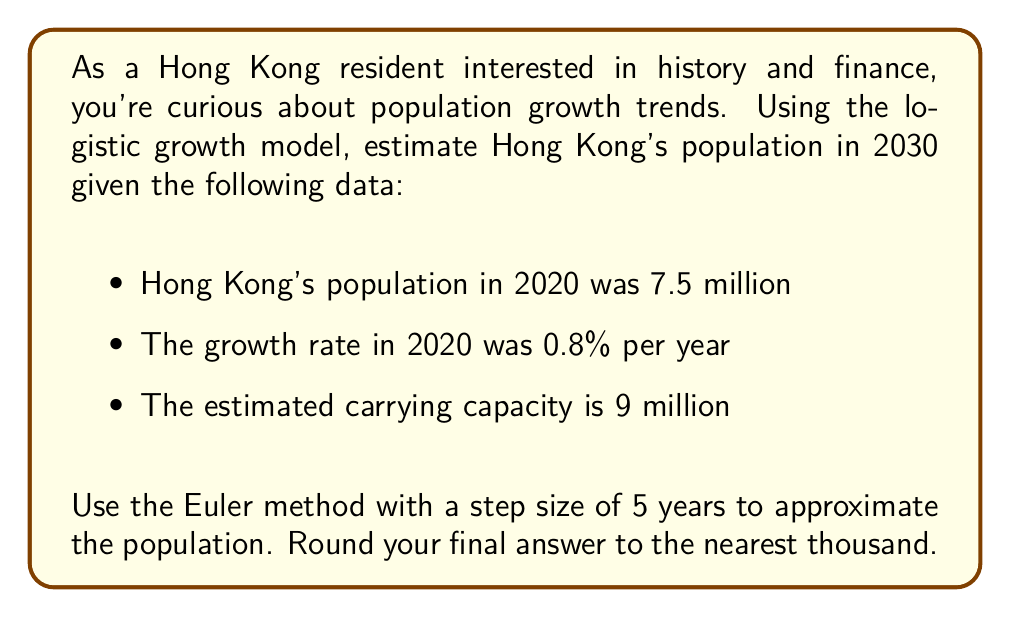Can you solve this math problem? To solve this problem, we'll use the logistic growth model and the Euler method for numerical approximation.

1) The logistic growth model is given by the differential equation:

   $$\frac{dP}{dt} = rP(1 - \frac{P}{K})$$

   where $P$ is the population, $t$ is time, $r$ is the growth rate, and $K$ is the carrying capacity.

2) Given:
   - $P(2020) = 7.5$ million
   - $r = 0.008$ (0.8% per year)
   - $K = 9$ million
   - Step size $h = 5$ years

3) The Euler method is given by:

   $$P_{n+1} = P_n + h \cdot f(t_n, P_n)$$

   where $f(t, P) = rP(1 - \frac{P}{K})$

4) Let's calculate two steps:

   Step 1 (2020 to 2025):
   $$\begin{align*}
   P_1 &= P_0 + h \cdot r P_0 (1 - \frac{P_0}{K}) \\
   &= 7.5 + 5 \cdot 0.008 \cdot 7.5 \cdot (1 - \frac{7.5}{9}) \\
   &= 7.5 + 0.05 \\
   &= 7.55 \text{ million}
   \end{align*}$$

   Step 2 (2025 to 2030):
   $$\begin{align*}
   P_2 &= P_1 + h \cdot r P_1 (1 - \frac{P_1}{K}) \\
   &= 7.55 + 5 \cdot 0.008 \cdot 7.55 \cdot (1 - \frac{7.55}{9}) \\
   &= 7.55 + 0.0472 \\
   &= 7.5972 \text{ million}
   \end{align*}$$

5) Rounding to the nearest thousand:
   7.5972 million ≈ 7,597,000
Answer: 7,597,000 